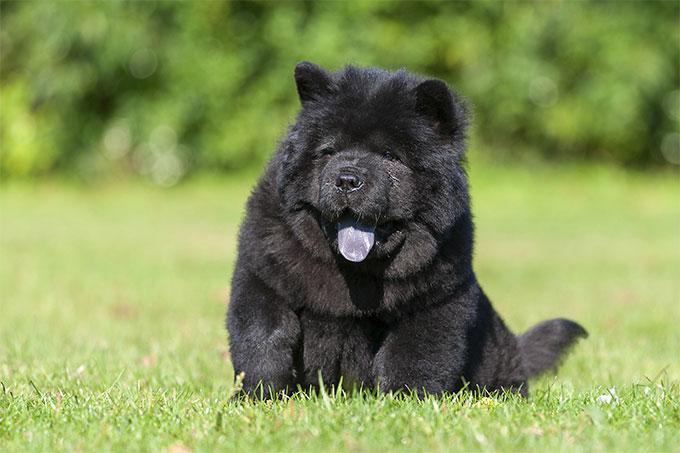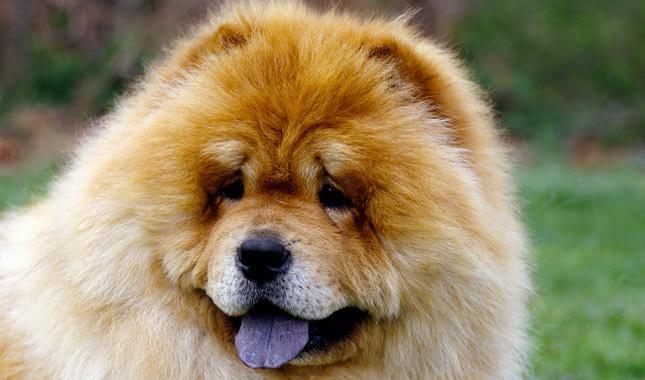The first image is the image on the left, the second image is the image on the right. Analyze the images presented: Is the assertion "A chow dog is shown standing on brick." valid? Answer yes or no. No. 